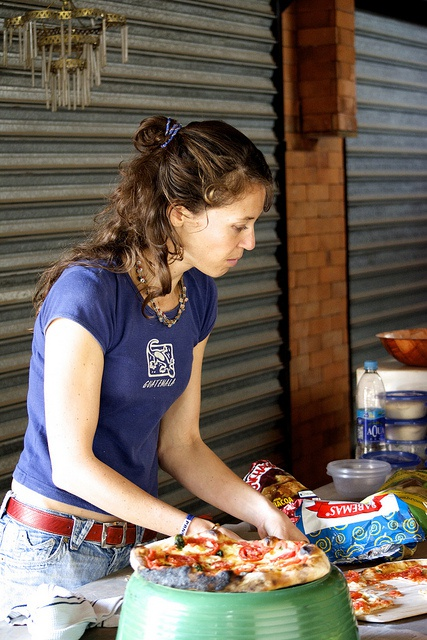Describe the objects in this image and their specific colors. I can see people in black, white, navy, and tan tones, pizza in black, ivory, darkgray, orange, and red tones, pizza in black, tan, and ivory tones, bottle in black, lightgray, navy, gray, and darkgray tones, and pizza in black, red, tan, and white tones in this image. 